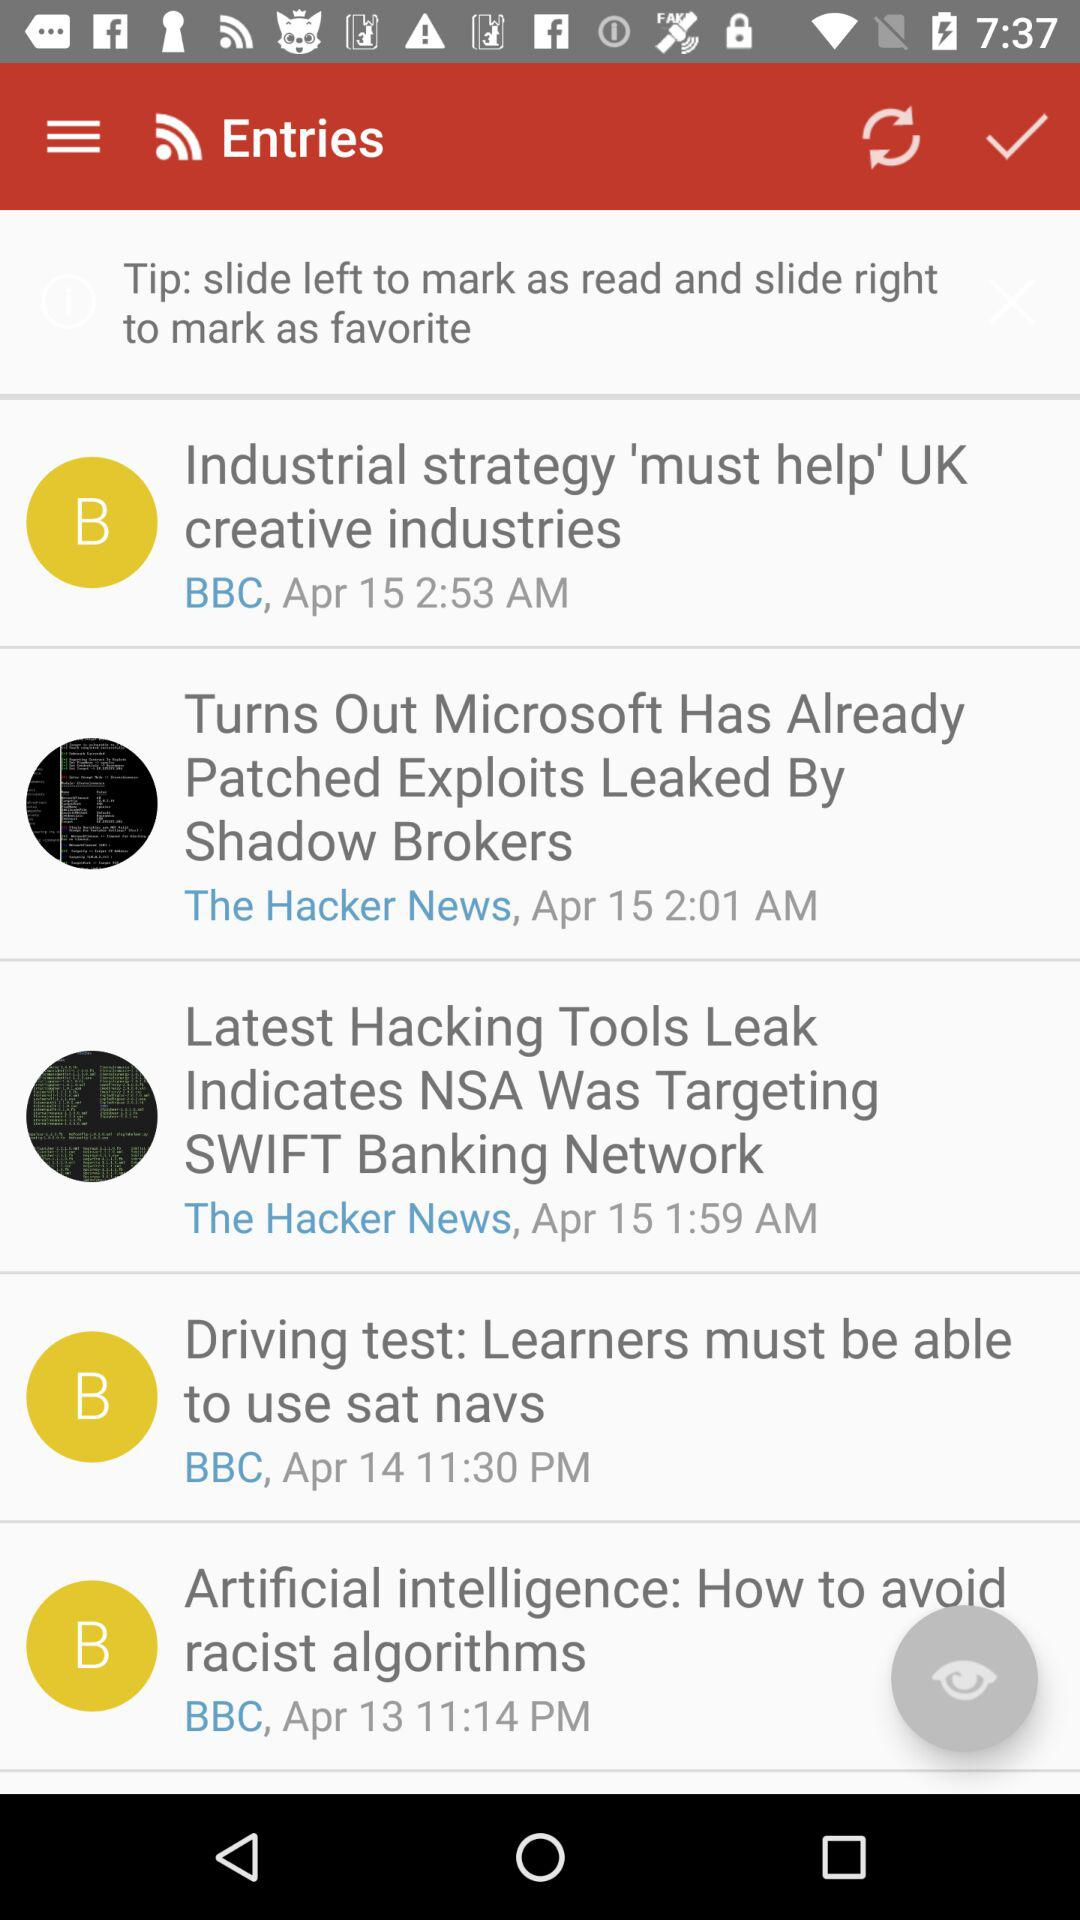What is the time of the entry "Turs Out Microsoft Has Already Patched Exploits Leaked By Shadow Brokers" received? The entry was received at 2:01 AM. 